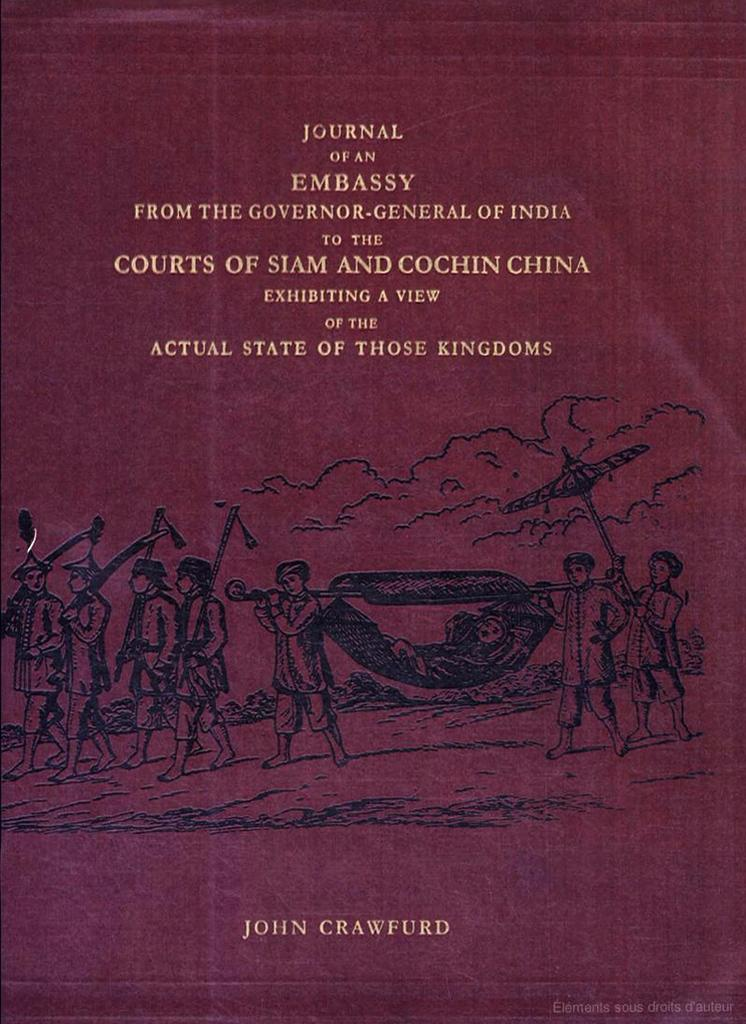Provide a one-sentence caption for the provided image. A diary relating to the establishment of an embassy is written by John Crawfurd. 